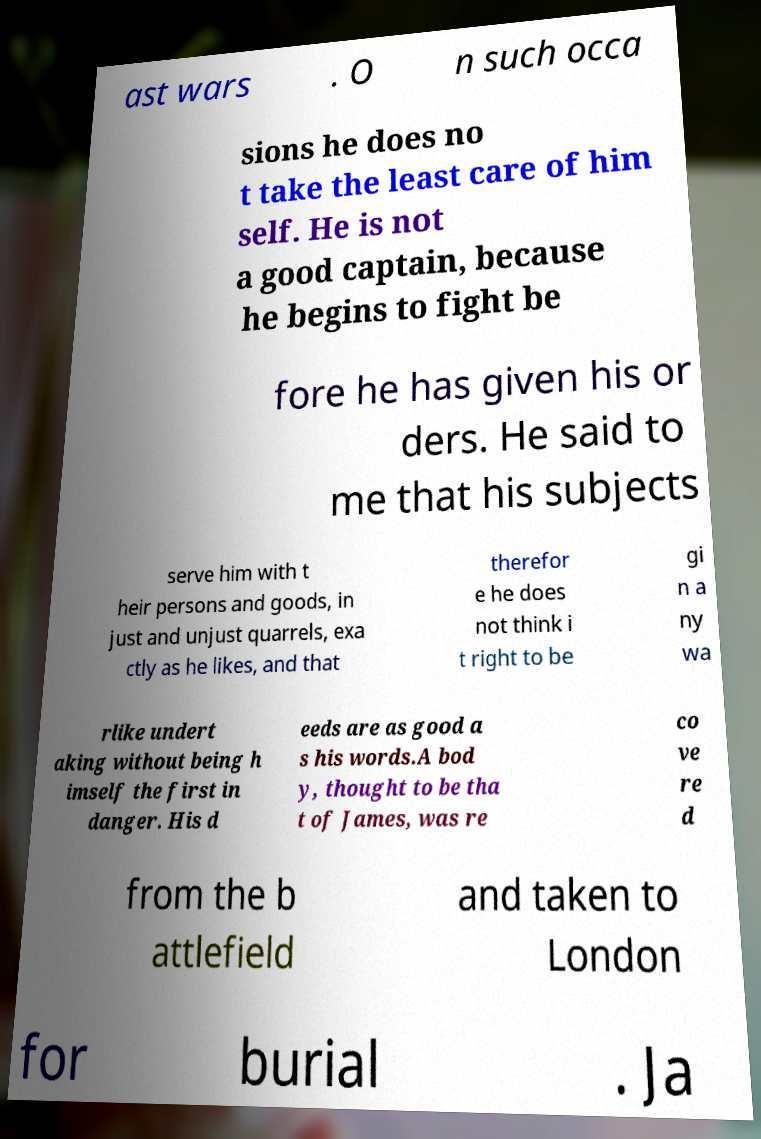Could you assist in decoding the text presented in this image and type it out clearly? ast wars . O n such occa sions he does no t take the least care of him self. He is not a good captain, because he begins to fight be fore he has given his or ders. He said to me that his subjects serve him with t heir persons and goods, in just and unjust quarrels, exa ctly as he likes, and that therefor e he does not think i t right to be gi n a ny wa rlike undert aking without being h imself the first in danger. His d eeds are as good a s his words.A bod y, thought to be tha t of James, was re co ve re d from the b attlefield and taken to London for burial . Ja 